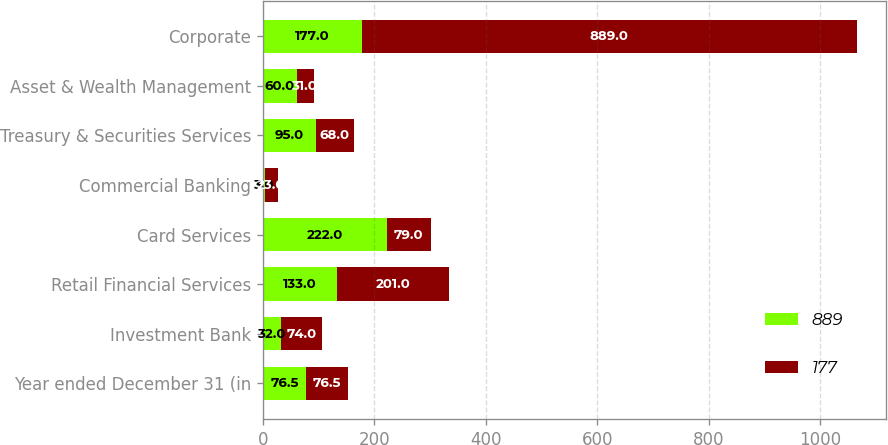<chart> <loc_0><loc_0><loc_500><loc_500><stacked_bar_chart><ecel><fcel>Year ended December 31 (in<fcel>Investment Bank<fcel>Retail Financial Services<fcel>Card Services<fcel>Commercial Banking<fcel>Treasury & Securities Services<fcel>Asset & Wealth Management<fcel>Corporate<nl><fcel>889<fcel>76.5<fcel>32<fcel>133<fcel>222<fcel>3<fcel>95<fcel>60<fcel>177<nl><fcel>177<fcel>76.5<fcel>74<fcel>201<fcel>79<fcel>23<fcel>68<fcel>31<fcel>889<nl></chart> 